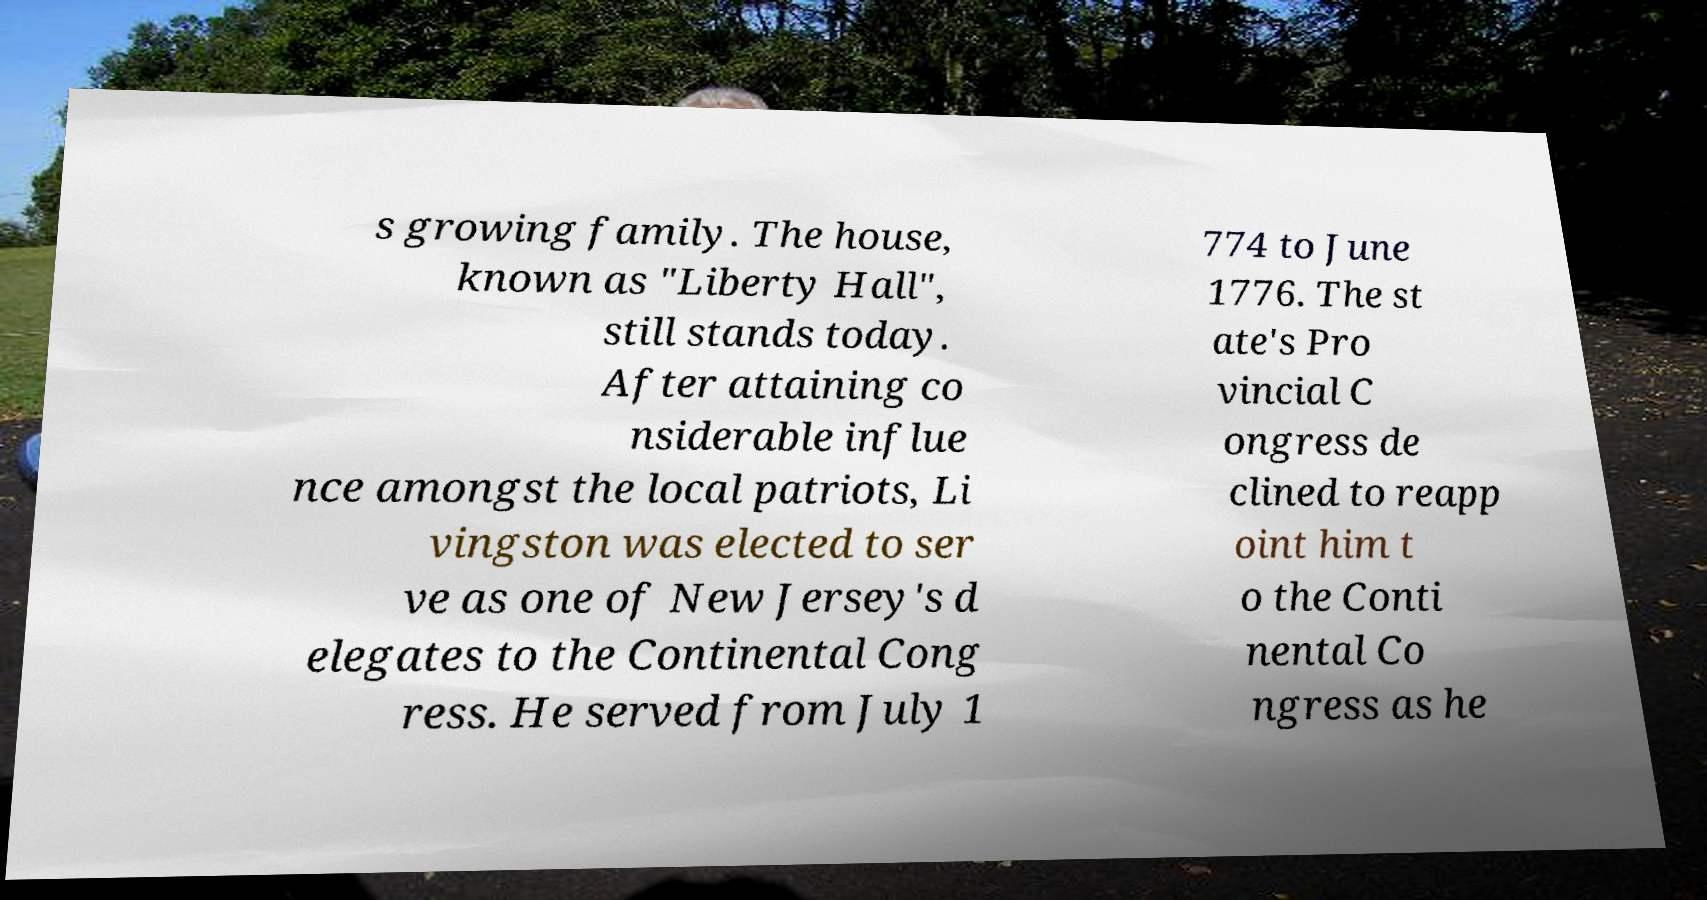Could you extract and type out the text from this image? s growing family. The house, known as "Liberty Hall", still stands today. After attaining co nsiderable influe nce amongst the local patriots, Li vingston was elected to ser ve as one of New Jersey's d elegates to the Continental Cong ress. He served from July 1 774 to June 1776. The st ate's Pro vincial C ongress de clined to reapp oint him t o the Conti nental Co ngress as he 